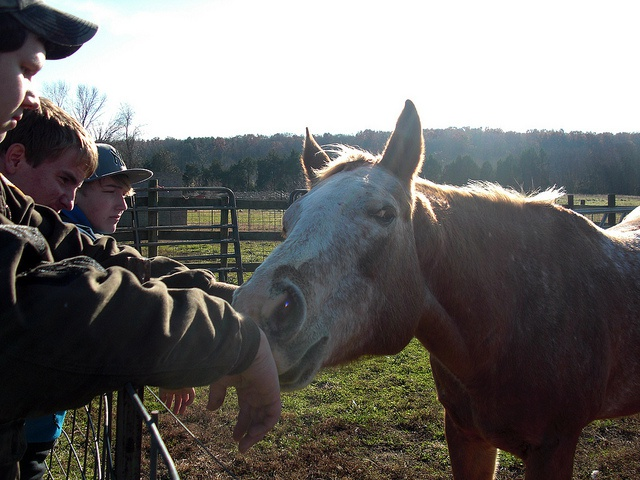Describe the objects in this image and their specific colors. I can see horse in darkblue, black, gray, and ivory tones, people in darkblue, black, gray, and darkgray tones, people in darkblue, black, ivory, and gray tones, and people in darkblue, black, and navy tones in this image. 